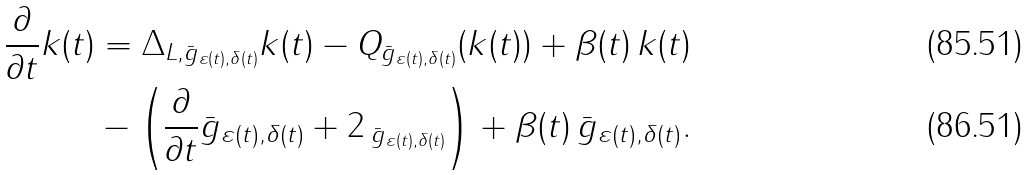Convert formula to latex. <formula><loc_0><loc_0><loc_500><loc_500>\frac { \partial } { \partial t } k ( t ) & = \Delta _ { L , \bar { g } _ { \varepsilon ( t ) , \delta ( t ) } } k ( t ) - Q _ { \bar { g } _ { \varepsilon ( t ) , \delta ( t ) } } ( k ( t ) ) + \beta ( t ) \, k ( t ) \\ & - \left ( \frac { \partial } { \partial t } \bar { g } _ { \varepsilon ( t ) , \delta ( t ) } + 2 \, _ { \bar { g } _ { \varepsilon ( t ) , \delta ( t ) } } \right ) + \beta ( t ) \, \bar { g } _ { \varepsilon ( t ) , \delta ( t ) } .</formula> 